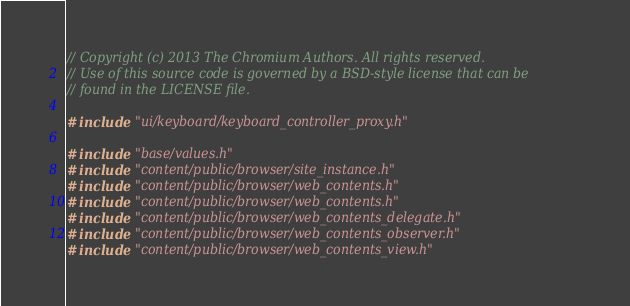<code> <loc_0><loc_0><loc_500><loc_500><_C++_>// Copyright (c) 2013 The Chromium Authors. All rights reserved.
// Use of this source code is governed by a BSD-style license that can be
// found in the LICENSE file.

#include "ui/keyboard/keyboard_controller_proxy.h"

#include "base/values.h"
#include "content/public/browser/site_instance.h"
#include "content/public/browser/web_contents.h"
#include "content/public/browser/web_contents.h"
#include "content/public/browser/web_contents_delegate.h"
#include "content/public/browser/web_contents_observer.h"
#include "content/public/browser/web_contents_view.h"</code> 